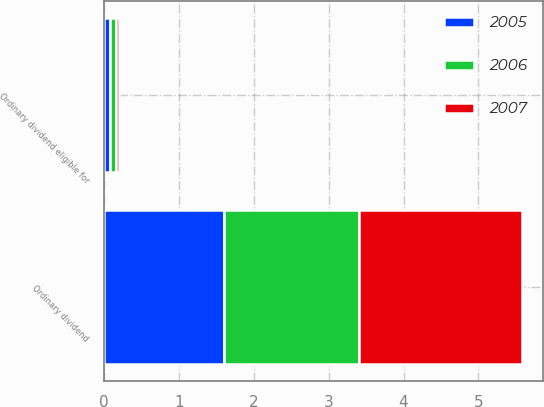Convert chart. <chart><loc_0><loc_0><loc_500><loc_500><stacked_bar_chart><ecel><fcel>Ordinary dividend<fcel>Ordinary dividend eligible for<nl><fcel>2007<fcel>2.17<fcel>0.04<nl><fcel>2006<fcel>1.81<fcel>0.07<nl><fcel>2005<fcel>1.6<fcel>0.09<nl></chart> 